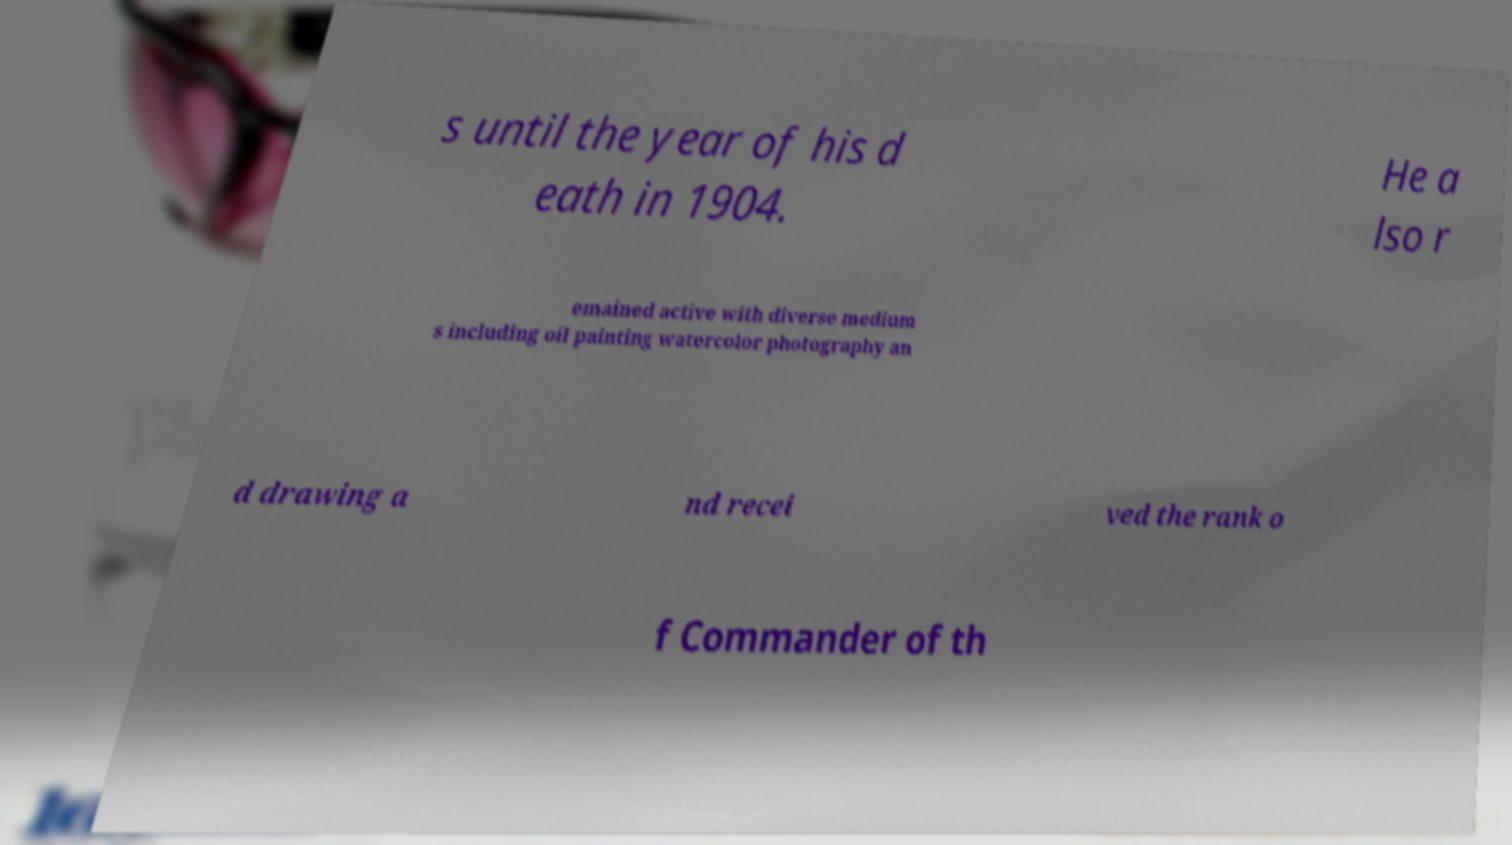Can you read and provide the text displayed in the image?This photo seems to have some interesting text. Can you extract and type it out for me? s until the year of his d eath in 1904. He a lso r emained active with diverse medium s including oil painting watercolor photography an d drawing a nd recei ved the rank o f Commander of th 